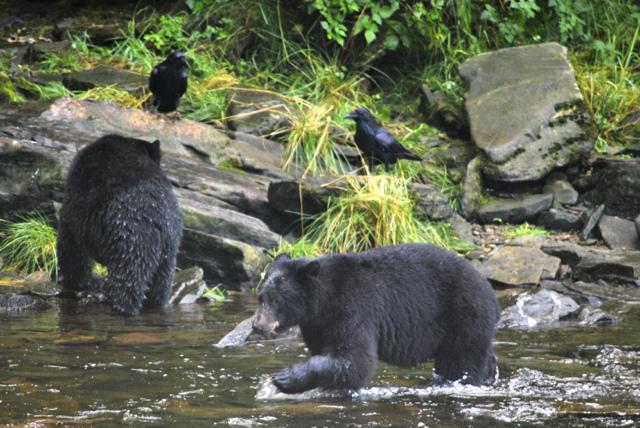Can the bears stand cold water?
Answer briefly. Yes. What is behind the bear?
Give a very brief answer. Rocks. Are the bears standing?
Be succinct. Yes. Are the bears wet or dry?
Answer briefly. Wet. Is one bear following another bear?
Give a very brief answer. No. Is the bear hungry?
Answer briefly. Yes. How many bears are there?
Give a very brief answer. 2. 